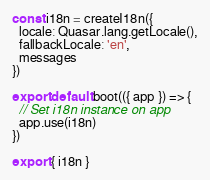<code> <loc_0><loc_0><loc_500><loc_500><_JavaScript_>const i18n = createI18n({
  locale: Quasar.lang.getLocale(),
  fallbackLocale: 'en',
  messages
})

export default boot(({ app }) => {
  // Set i18n instance on app
  app.use(i18n)
})

export { i18n }
</code> 